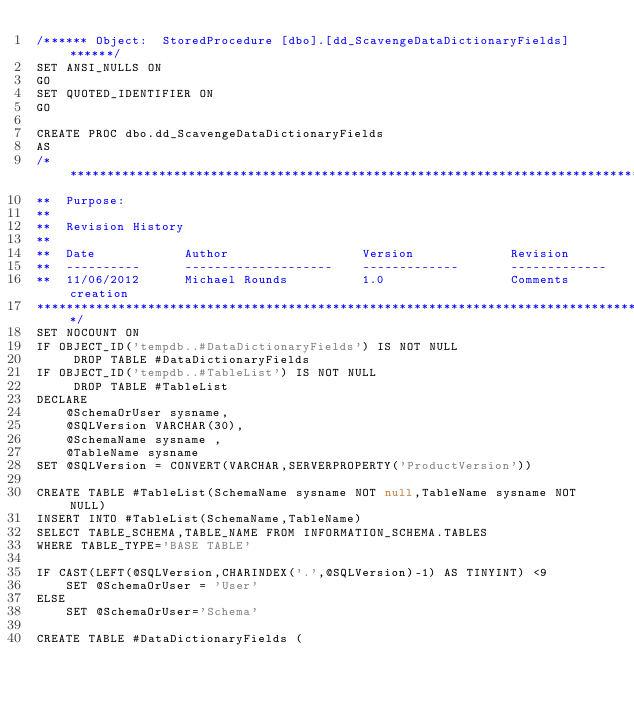<code> <loc_0><loc_0><loc_500><loc_500><_SQL_>/****** Object:  StoredProcedure [dbo].[dd_ScavengeDataDictionaryFields] ******/
SET ANSI_NULLS ON
GO
SET QUOTED_IDENTIFIER ON
GO

CREATE PROC dbo.dd_ScavengeDataDictionaryFields
AS
/**************************************************************************************************************
**  Purpose:
**
**  Revision History  
**  
**  Date			Author					Version				Revision  
**  ----------		--------------------	-------------		-------------
**  11/06/2012		Michael Rounds			1.0					Comments creation
***************************************************************************************************************/
SET NOCOUNT ON
IF OBJECT_ID('tempdb..#DataDictionaryFields') IS NOT NULL
     DROP TABLE #DataDictionaryFields
IF OBJECT_ID('tempdb..#TableList') IS NOT NULL
     DROP TABLE #TableList
DECLARE 
    @SchemaOrUser sysname,
    @SQLVersion VARCHAR(30),
    @SchemaName sysname ,
    @TableName sysname
SET @SQLVersion = CONVERT(VARCHAR,SERVERPROPERTY('ProductVersion'))

CREATE TABLE #TableList(SchemaName sysname NOT null,TableName sysname NOT NULL)
INSERT INTO #TableList(SchemaName,TableName)
SELECT TABLE_SCHEMA,TABLE_NAME FROM INFORMATION_SCHEMA.TABLES
WHERE TABLE_TYPE='BASE TABLE'

IF CAST(LEFT(@SQLVersion,CHARINDEX('.',@SQLVersion)-1) AS TINYINT) <9
    SET @SchemaOrUser = 'User'
ELSE
    SET @SchemaOrUser='Schema'

CREATE TABLE #DataDictionaryFields (</code> 